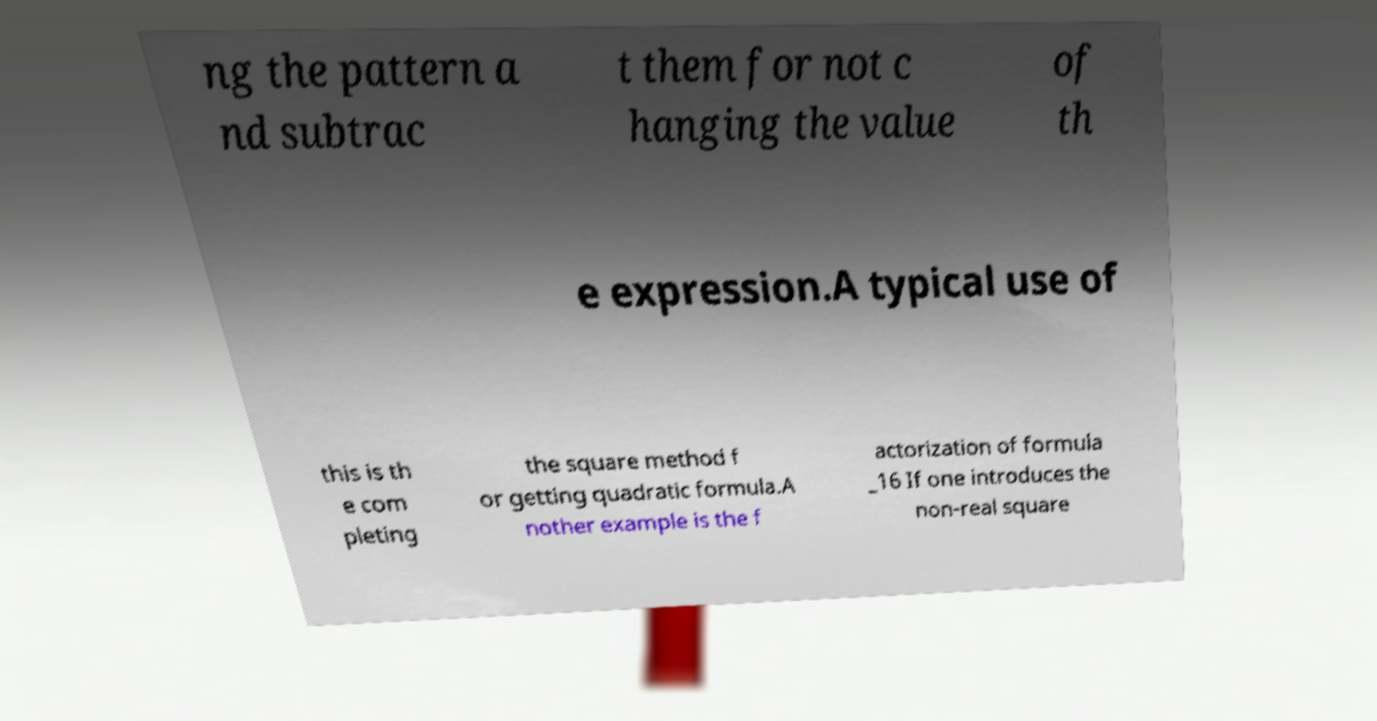There's text embedded in this image that I need extracted. Can you transcribe it verbatim? ng the pattern a nd subtrac t them for not c hanging the value of th e expression.A typical use of this is th e com pleting the square method f or getting quadratic formula.A nother example is the f actorization of formula _16 If one introduces the non-real square 